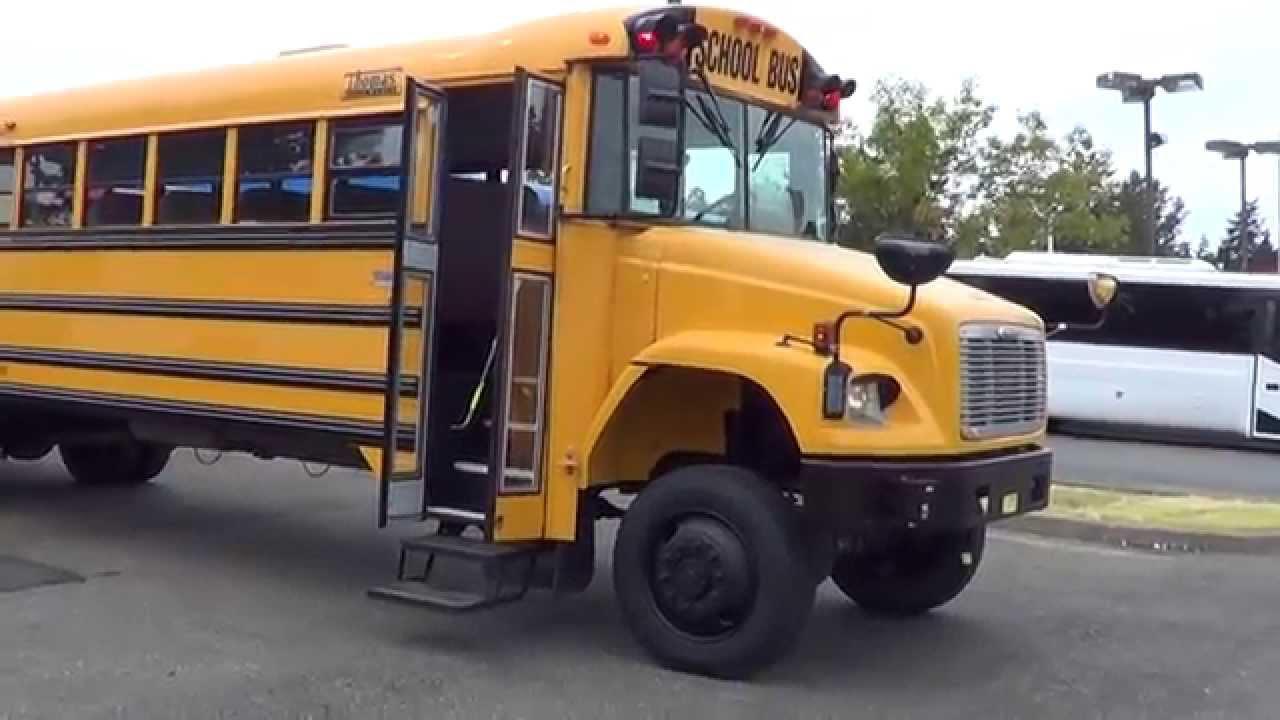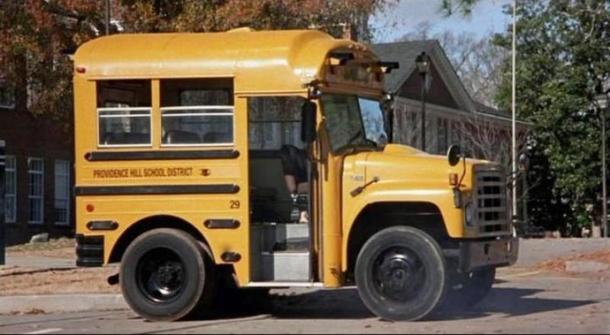The first image is the image on the left, the second image is the image on the right. For the images displayed, is the sentence "The combined images show two buses heading in the same direction with a shorter bus appearing to be leading." factually correct? Answer yes or no. Yes. The first image is the image on the left, the second image is the image on the right. Considering the images on both sides, is "A bus' left side is visible." valid? Answer yes or no. No. 